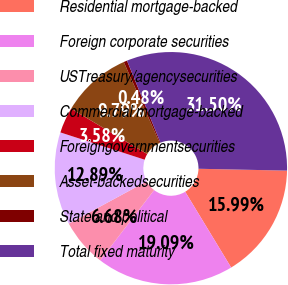Convert chart. <chart><loc_0><loc_0><loc_500><loc_500><pie_chart><fcel>Residential mortgage-backed<fcel>Foreign corporate securities<fcel>USTreasury/agencysecurities<fcel>Commercial mortgage-backed<fcel>Foreigngovernmentsecurities<fcel>Asset-backedsecurities<fcel>State and political<fcel>Total fixed maturity<nl><fcel>15.99%<fcel>19.09%<fcel>6.68%<fcel>12.89%<fcel>3.58%<fcel>9.79%<fcel>0.48%<fcel>31.5%<nl></chart> 